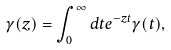Convert formula to latex. <formula><loc_0><loc_0><loc_500><loc_500>\gamma ( z ) = \int _ { 0 } ^ { \infty } d t e ^ { - z t } \gamma ( t ) ,</formula> 